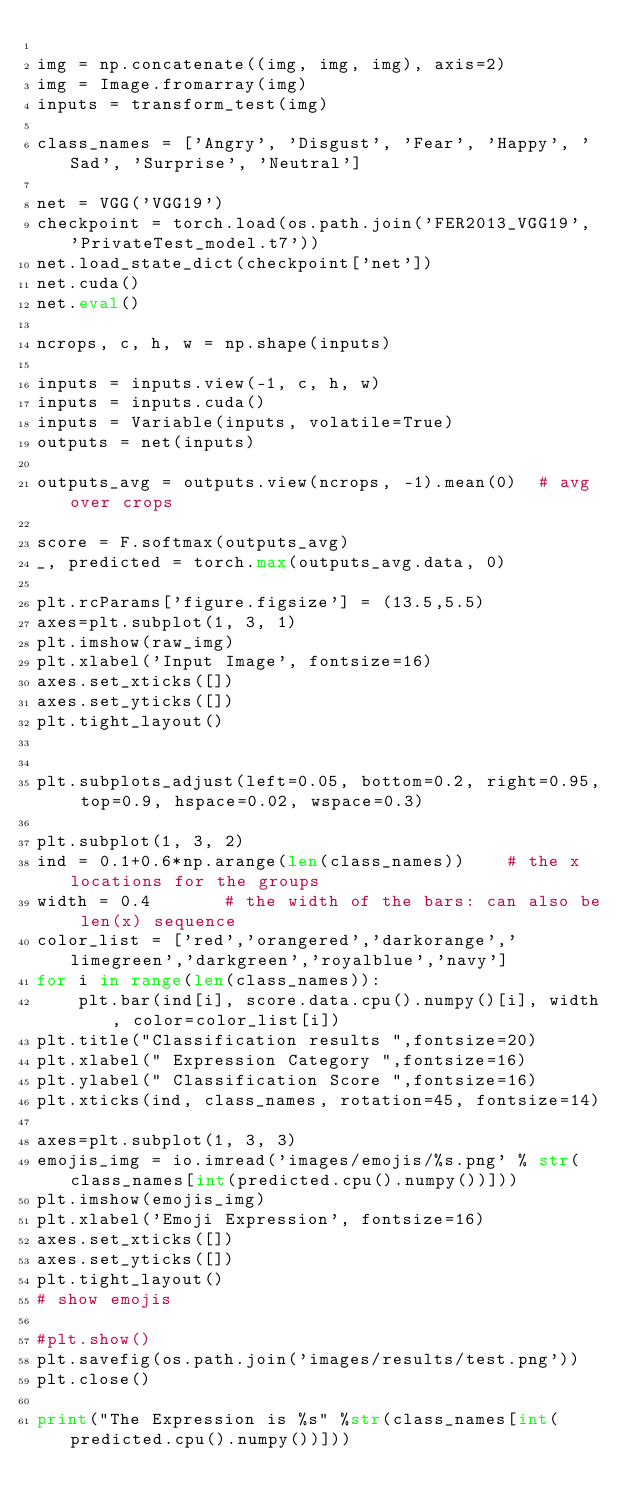<code> <loc_0><loc_0><loc_500><loc_500><_Python_>
img = np.concatenate((img, img, img), axis=2)
img = Image.fromarray(img)
inputs = transform_test(img)

class_names = ['Angry', 'Disgust', 'Fear', 'Happy', 'Sad', 'Surprise', 'Neutral']

net = VGG('VGG19')
checkpoint = torch.load(os.path.join('FER2013_VGG19', 'PrivateTest_model.t7'))
net.load_state_dict(checkpoint['net'])
net.cuda()
net.eval()

ncrops, c, h, w = np.shape(inputs)

inputs = inputs.view(-1, c, h, w)
inputs = inputs.cuda()
inputs = Variable(inputs, volatile=True)
outputs = net(inputs)

outputs_avg = outputs.view(ncrops, -1).mean(0)  # avg over crops

score = F.softmax(outputs_avg)
_, predicted = torch.max(outputs_avg.data, 0)

plt.rcParams['figure.figsize'] = (13.5,5.5)
axes=plt.subplot(1, 3, 1)
plt.imshow(raw_img)
plt.xlabel('Input Image', fontsize=16)
axes.set_xticks([])
axes.set_yticks([])
plt.tight_layout()


plt.subplots_adjust(left=0.05, bottom=0.2, right=0.95, top=0.9, hspace=0.02, wspace=0.3)

plt.subplot(1, 3, 2)
ind = 0.1+0.6*np.arange(len(class_names))    # the x locations for the groups
width = 0.4       # the width of the bars: can also be len(x) sequence
color_list = ['red','orangered','darkorange','limegreen','darkgreen','royalblue','navy']
for i in range(len(class_names)):
    plt.bar(ind[i], score.data.cpu().numpy()[i], width, color=color_list[i])
plt.title("Classification results ",fontsize=20)
plt.xlabel(" Expression Category ",fontsize=16)
plt.ylabel(" Classification Score ",fontsize=16)
plt.xticks(ind, class_names, rotation=45, fontsize=14)

axes=plt.subplot(1, 3, 3)
emojis_img = io.imread('images/emojis/%s.png' % str(class_names[int(predicted.cpu().numpy())]))
plt.imshow(emojis_img)
plt.xlabel('Emoji Expression', fontsize=16)
axes.set_xticks([])
axes.set_yticks([])
plt.tight_layout()
# show emojis

#plt.show()
plt.savefig(os.path.join('images/results/test.png'))
plt.close()

print("The Expression is %s" %str(class_names[int(predicted.cpu().numpy())]))


</code> 